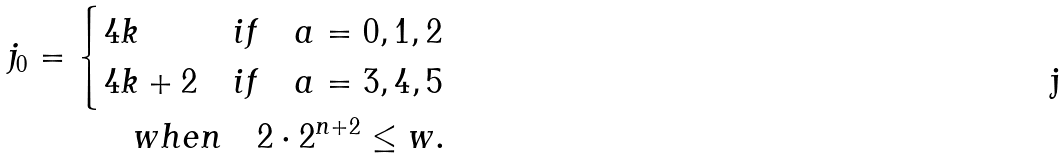Convert formula to latex. <formula><loc_0><loc_0><loc_500><loc_500>j _ { 0 } = \begin{cases} 4 k & i f \quad a = 0 , 1 , 2 \\ 4 k + 2 & i f \quad a = 3 , 4 , 5 \end{cases} \\ \quad w h e n \quad 2 \cdot 2 ^ { n + 2 } \leq w .</formula> 